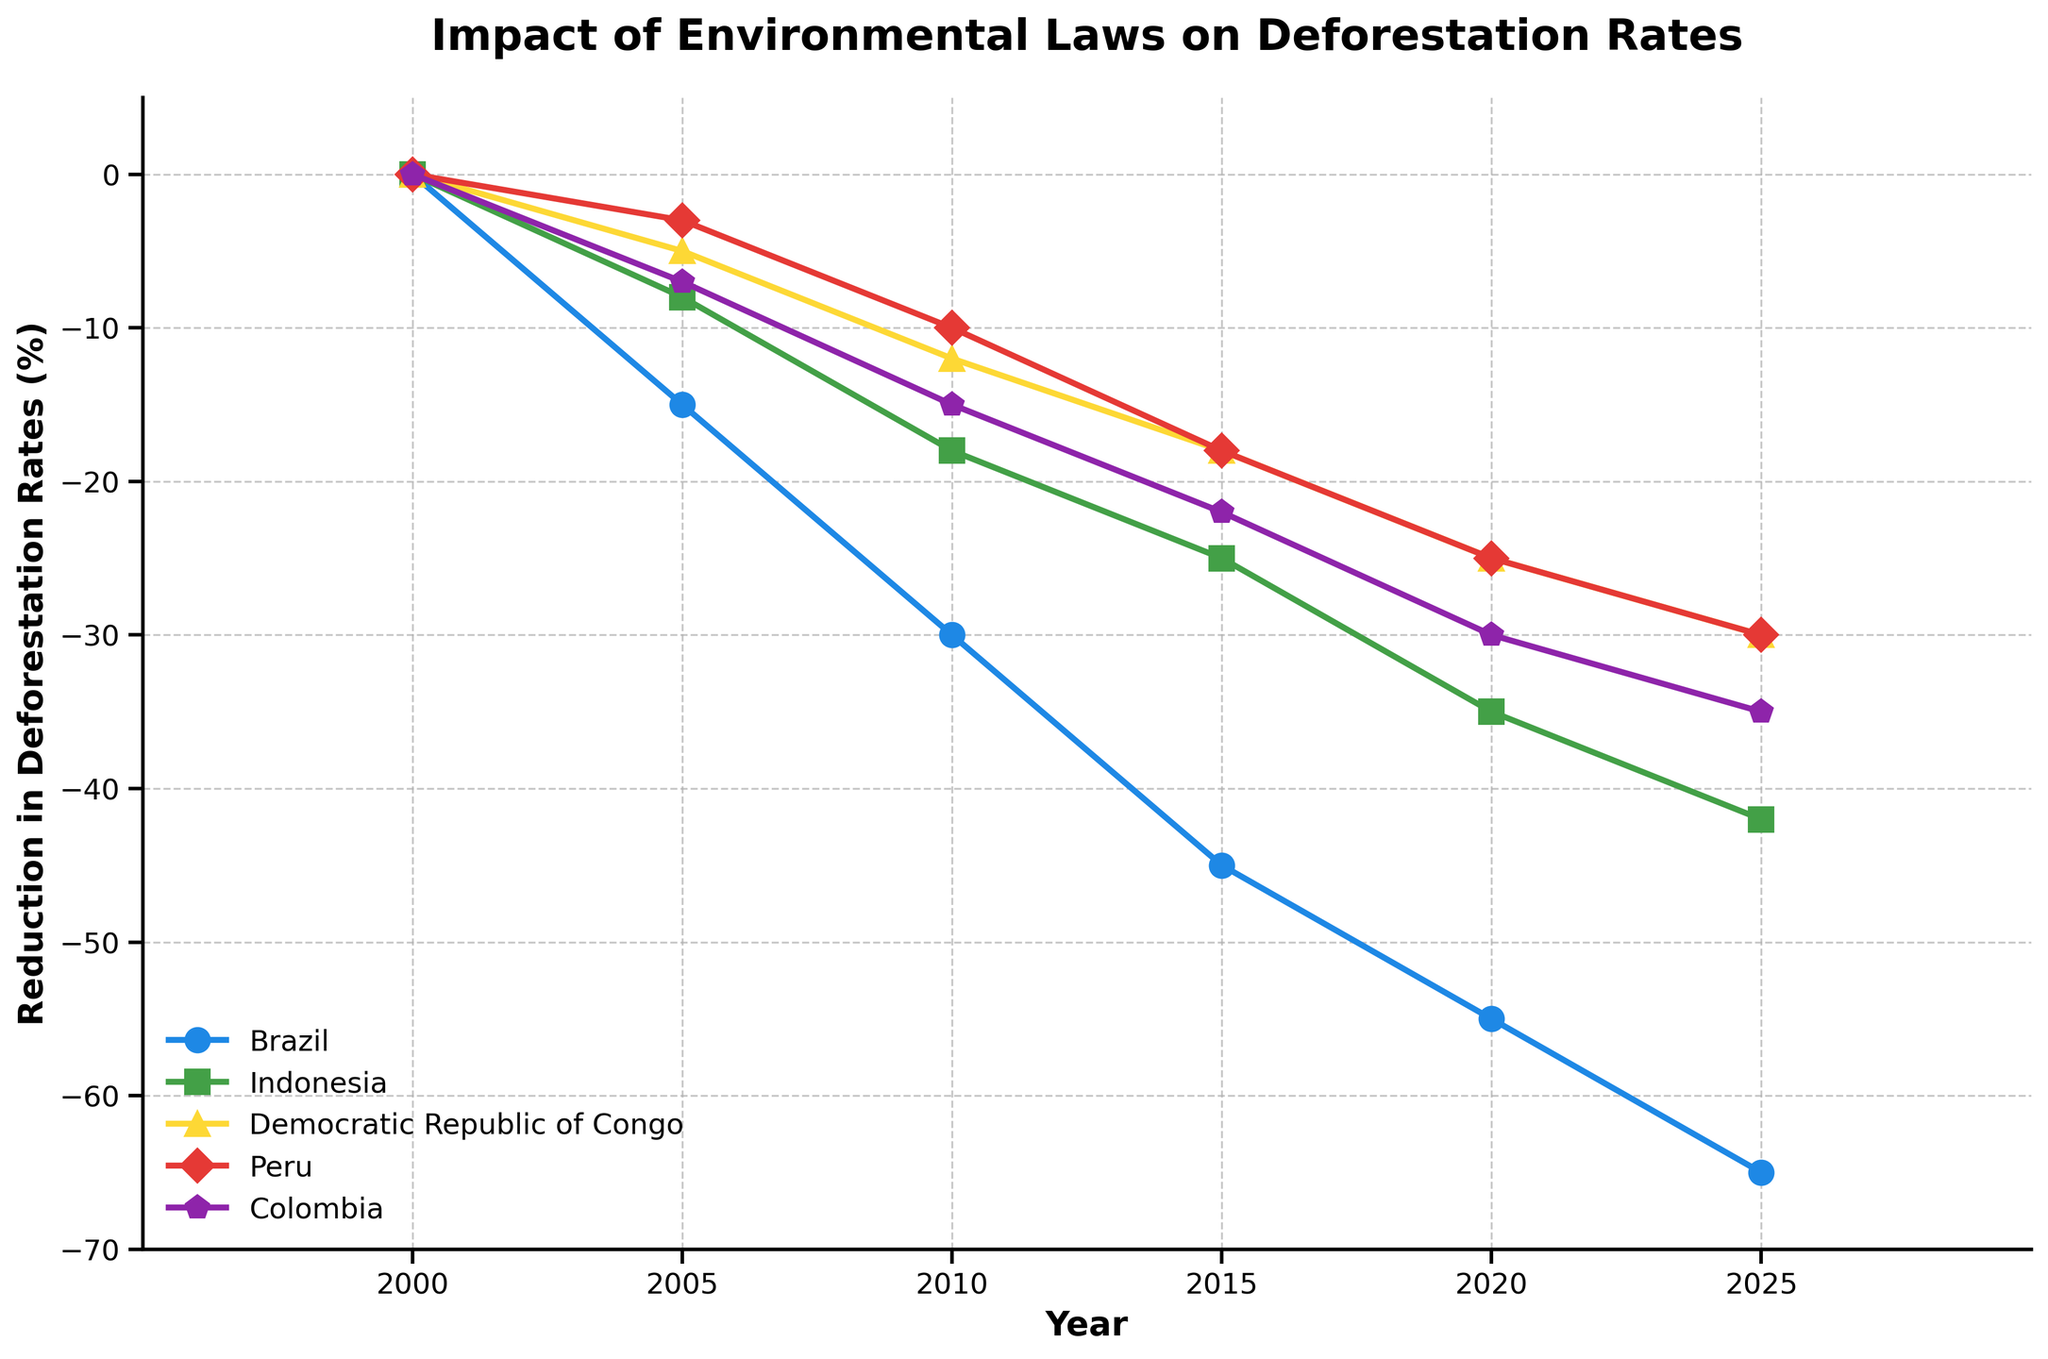What is the trend in the reduction of deforestation rates in Brazil from 2000 to 2025? The line representing Brazil starts at 0% reduction in 2000 and shows a consistent decline, reaching -65% by 2025. This indicates a significant and continuous reduction over the years.
Answer: Consistent decline to -65% Which country shows the smallest reduction in deforestation rates in 2025? By looking at the points on the 2025 marker, the Democratic Republic of Congo shows the smallest reduction at -30%.
Answer: Democratic Republic of Congo How does the deforestation reduction rate in Indonesia in 2020 compare to that in Peru in the same year? In 2020, Indonesia has a reduction rate of -35%, while Peru has -25%. This means Indonesia has a greater reduction by 10 percentage points.
Answer: Indonesia has a greater reduction by 10 percentage points What is the average reduction rate of deforestation in 2020 across all five countries? The reduction rates in 2020 for Brazil, Indonesia, Democratic Republic of Congo, Peru, and Colombia are -55%, -35%, -25%, -25%, and -30%, respectively. Summing these gives -170%, and dividing by 5 gives an average of -34%.
Answer: -34% Which country had the most significant decrease in deforestation rates between 2000 and 2025? From the values, Brazil had the most substantial reduction, going from 0% in 2000 to -65% in 2025.
Answer: Brazil Compare the rate of reduction in deforestation between Brazil and Colombia in 2010. In 2010, Brazil had a reduction of -30%, while Colombia had -15%. Brazil's reduction is 15 percentage points greater than Colombia's.
Answer: Brazil's reduction is 15 percentage points greater Which year saw the highest reduction in deforestation rates across all countries on average? Each year's average reduction can be calculated: 2000 (0%), 2005 (-7.6%), 2010 (-17%), 2015 (-25.6%), 2020 (-34%), 2025 (-40.4%). The highest reduction is in 2025.
Answer: 2025 What is the total reduction in deforestation rates for Peru from 2000 to 2025? Peru's reduction starts at 0% in 2000 and reaches -30% by 2025, indicating a total reduction of 30 percentage points.
Answer: 30 percentage points What color represents the Democratic Republic of Congo in the figure, and what is its reduction rate in 2015? The Democratic Republic of Congo is represented by the yellow line, and in 2015, its reduction rate is -18%.
Answer: Yellow, -18% Is there a year when Colombia's reduction rate aligns with the average reduction rate across all countries? If so, which year? To find the answer, compare Colombia's reduction rates with average rates calculated for each year: 2000 (0%), 2005 (-7.6%), 2010 (-17%), 2015 (-25.6%), 2020 (-34%), 2025 (-40.4%). In 2015, both Colombia's rate (-22%) and the average rate are close, indicating there's no exact match.
Answer: No exact match 